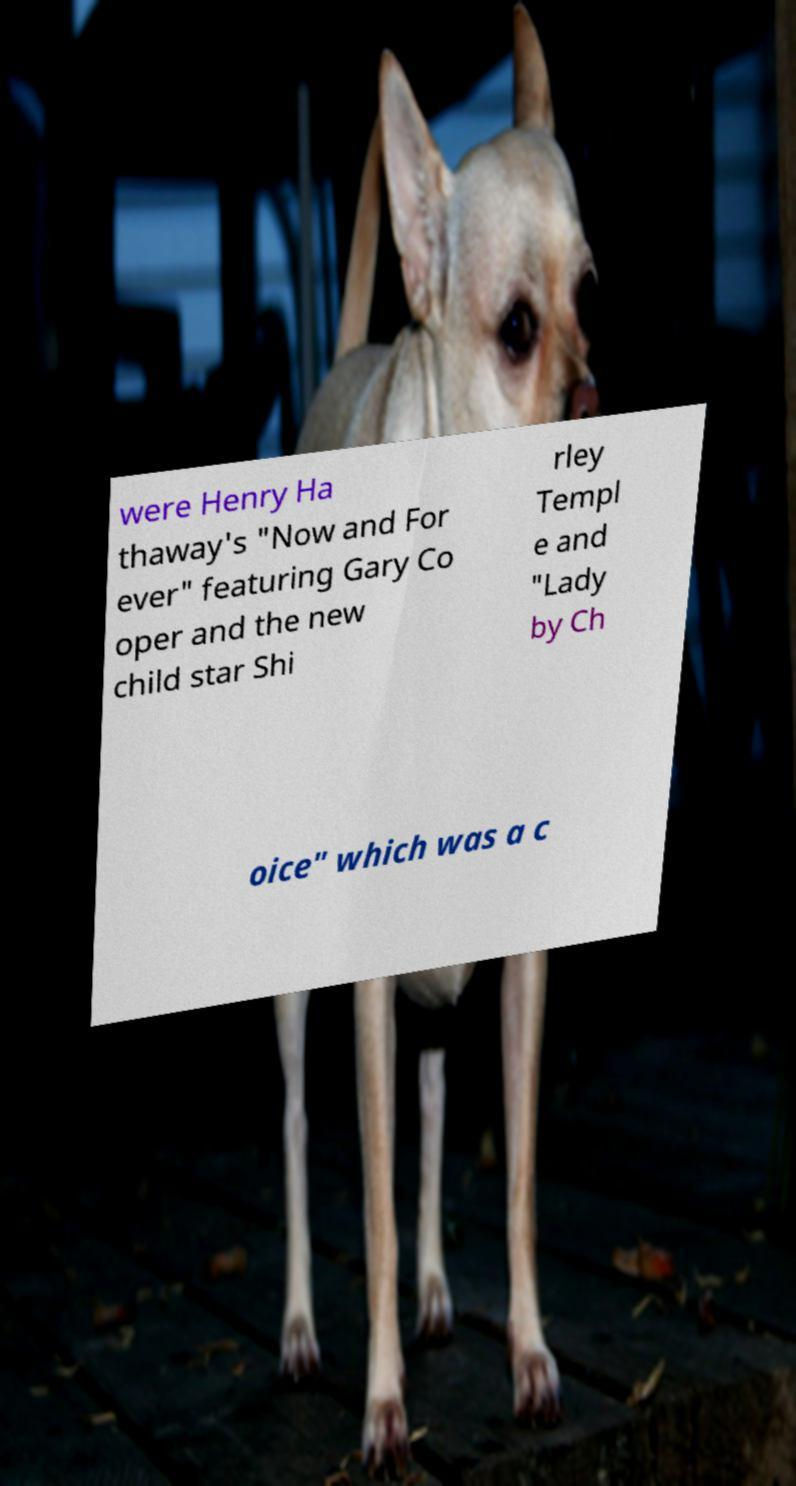Can you accurately transcribe the text from the provided image for me? were Henry Ha thaway's "Now and For ever" featuring Gary Co oper and the new child star Shi rley Templ e and "Lady by Ch oice" which was a c 